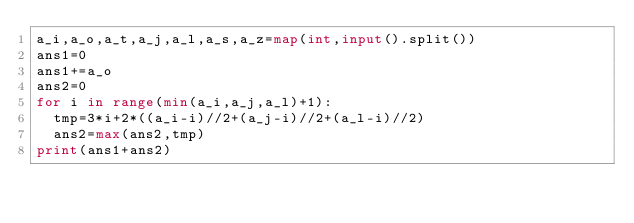Convert code to text. <code><loc_0><loc_0><loc_500><loc_500><_Python_>a_i,a_o,a_t,a_j,a_l,a_s,a_z=map(int,input().split())
ans1=0
ans1+=a_o
ans2=0
for i in range(min(a_i,a_j,a_l)+1):
  tmp=3*i+2*((a_i-i)//2+(a_j-i)//2+(a_l-i)//2)
  ans2=max(ans2,tmp)
print(ans1+ans2)</code> 